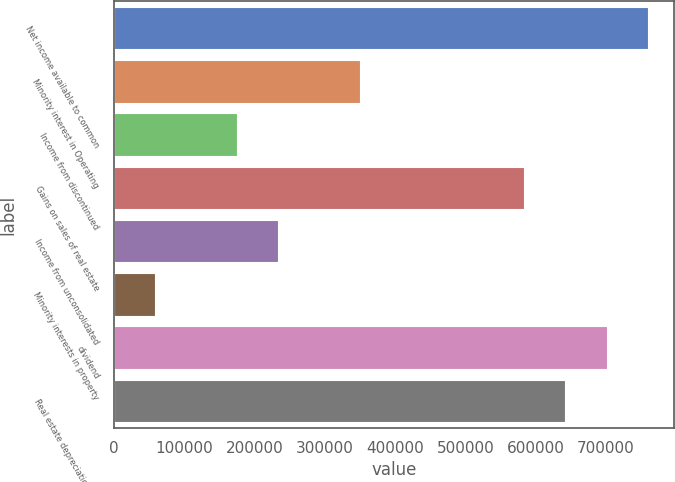Convert chart. <chart><loc_0><loc_0><loc_500><loc_500><bar_chart><fcel>Net income available to common<fcel>Minority interest in Operating<fcel>Income from discontinued<fcel>Gains on sales of real estate<fcel>Income from unconsolidated<fcel>Minority interests in property<fcel>dividend<fcel>Real estate depreciation and<nl><fcel>759068<fcel>350384<fcel>175234<fcel>583918<fcel>233617<fcel>58467.2<fcel>700685<fcel>642301<nl></chart> 